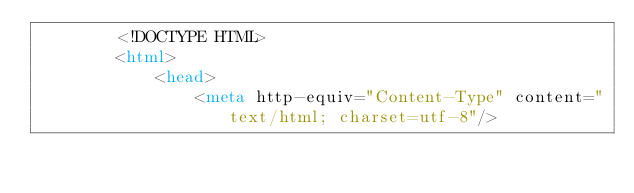<code> <loc_0><loc_0><loc_500><loc_500><_HTML_>        <!DOCTYPE HTML>
        <html>
            <head>
                <meta http-equiv="Content-Type" content="text/html; charset=utf-8"/></code> 